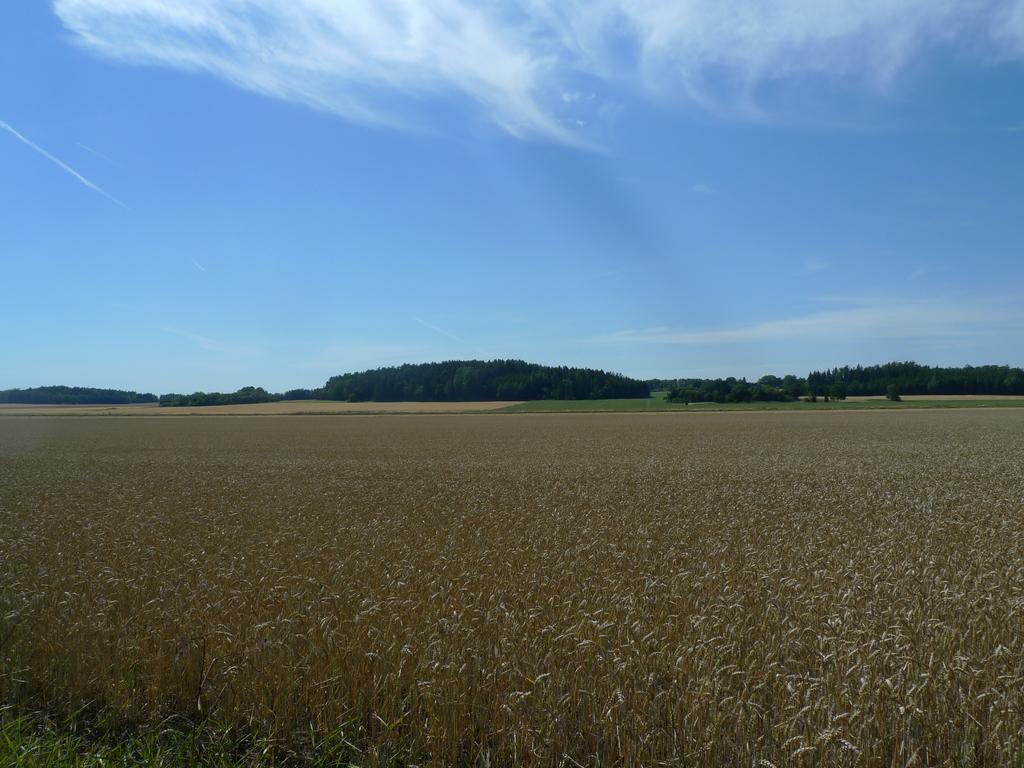What type of vegetation is present on the ground in the image? There are plants on the ground in the image. What can be seen in the background of the image? There are trees visible in the background of the image. What is visible at the top of the image? The sky is clear and visible at the top of the image. Can you touch the sofa in the image? There is no sofa present in the image; it features plants on the ground, trees in the background, and a clear sky. 